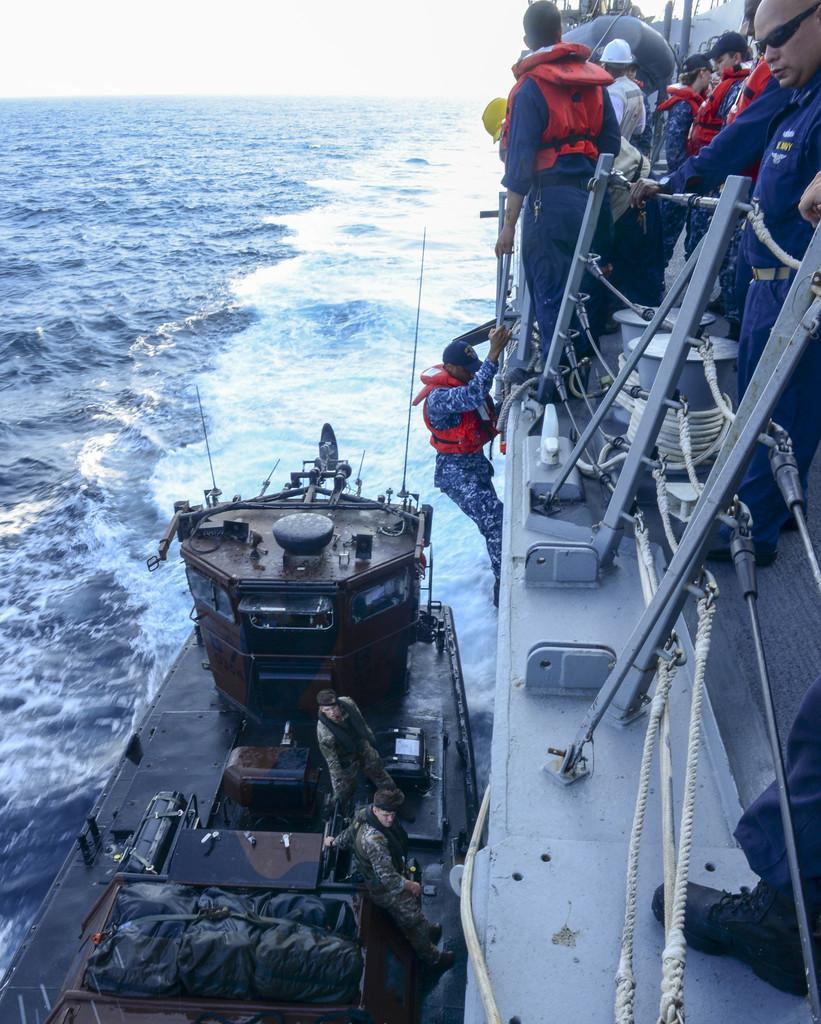In one or two sentences, can you explain what this image depicts? In this image we can see a group of people standing on the ships placed in water, we can also see some people wearing life jackets. On the right side of the image we can see some metal poles, ropes and some cables. At the top of the image we can see the sky. 